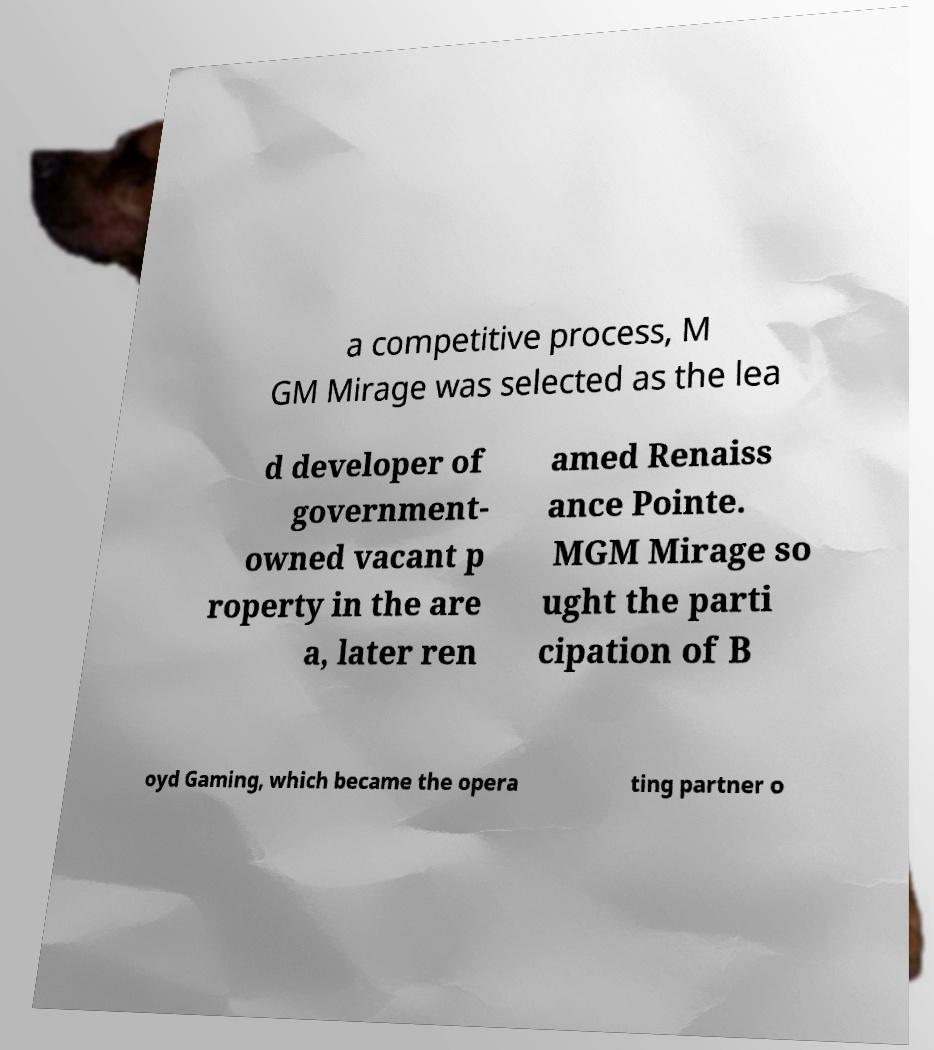For documentation purposes, I need the text within this image transcribed. Could you provide that? a competitive process, M GM Mirage was selected as the lea d developer of government- owned vacant p roperty in the are a, later ren amed Renaiss ance Pointe. MGM Mirage so ught the parti cipation of B oyd Gaming, which became the opera ting partner o 